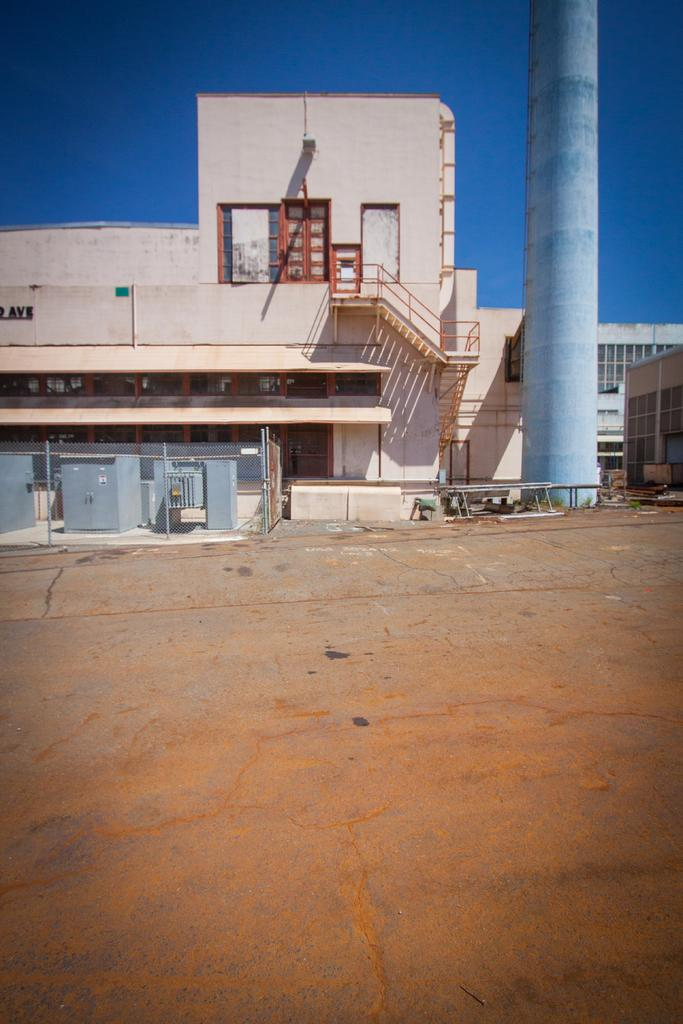What type of surface is visible in the image? There is a ground in the image. What type of structures can be seen in the image? There are buildings and a tower in the image. What else is present in the image besides structures? There are objects in the image. What can be seen in the distance in the image? The sky is visible in the background of the image. How does the mind expand in the image? There is no reference to a mind or its expansion in the image; it features a ground, buildings, a tower, objects, and the sky. 